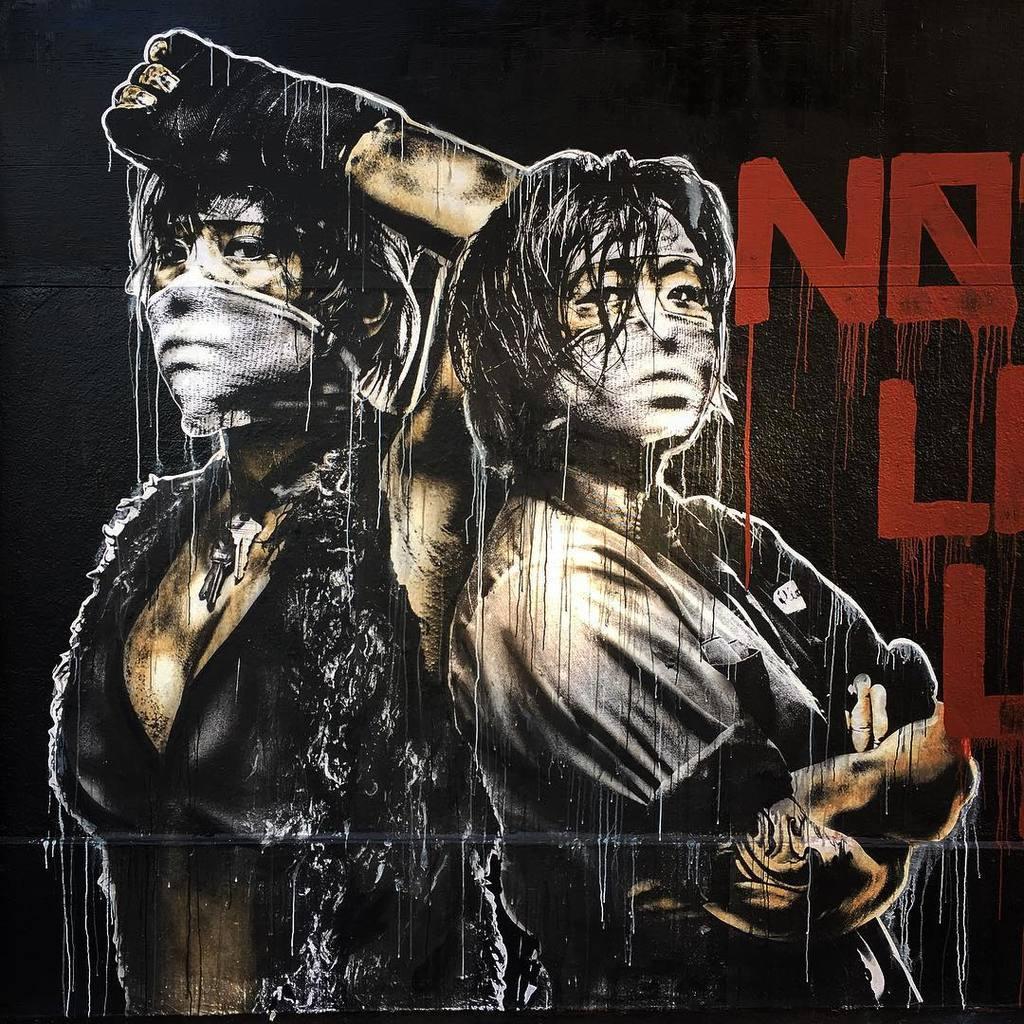Describe this image in one or two sentences. In this image we can see a poster, on the poster, we can see the persons and text. 